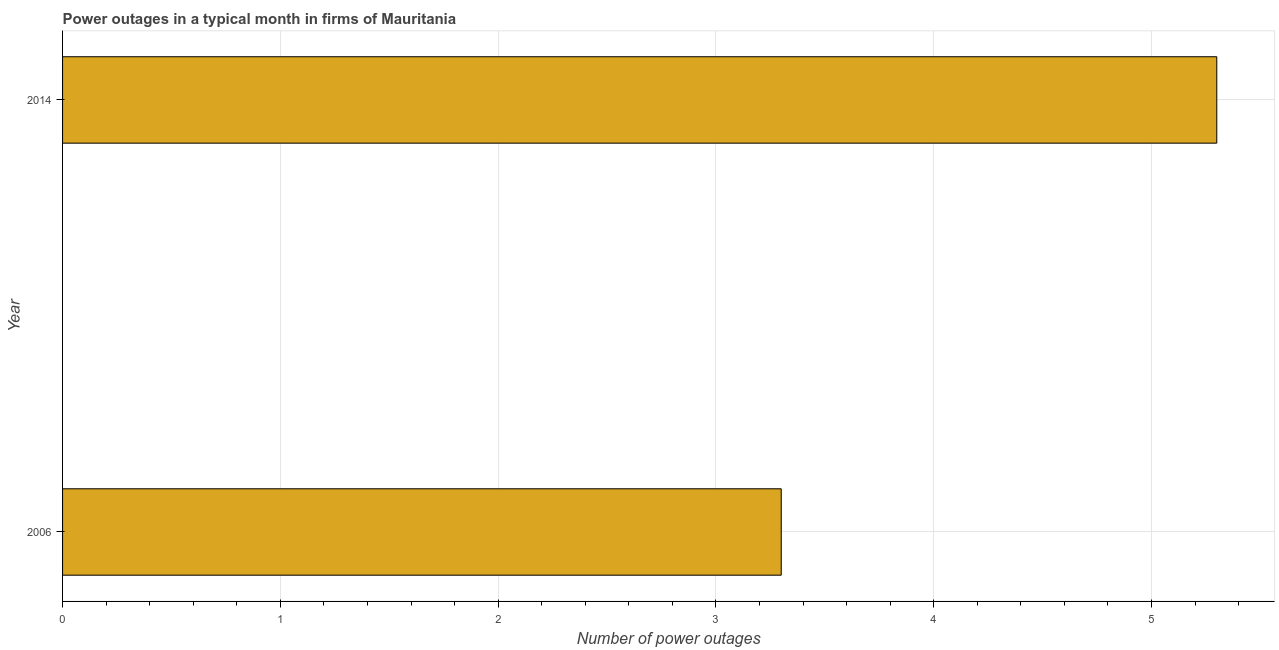What is the title of the graph?
Keep it short and to the point. Power outages in a typical month in firms of Mauritania. What is the label or title of the X-axis?
Give a very brief answer. Number of power outages. What is the label or title of the Y-axis?
Provide a short and direct response. Year. What is the number of power outages in 2014?
Provide a short and direct response. 5.3. In which year was the number of power outages maximum?
Your answer should be very brief. 2014. In which year was the number of power outages minimum?
Give a very brief answer. 2006. What is the sum of the number of power outages?
Your answer should be compact. 8.6. What is the average number of power outages per year?
Offer a very short reply. 4.3. What is the median number of power outages?
Offer a very short reply. 4.3. In how many years, is the number of power outages greater than 4.4 ?
Offer a terse response. 1. Do a majority of the years between 2014 and 2006 (inclusive) have number of power outages greater than 1 ?
Ensure brevity in your answer.  No. What is the ratio of the number of power outages in 2006 to that in 2014?
Your response must be concise. 0.62. Is the number of power outages in 2006 less than that in 2014?
Make the answer very short. Yes. How many bars are there?
Offer a very short reply. 2. How many years are there in the graph?
Provide a short and direct response. 2. What is the difference between two consecutive major ticks on the X-axis?
Provide a succinct answer. 1. What is the Number of power outages of 2006?
Make the answer very short. 3.3. What is the ratio of the Number of power outages in 2006 to that in 2014?
Keep it short and to the point. 0.62. 